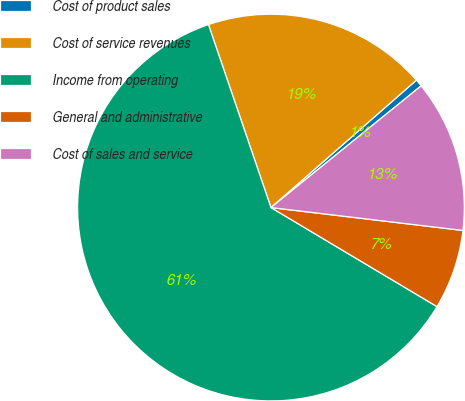<chart> <loc_0><loc_0><loc_500><loc_500><pie_chart><fcel>Cost of product sales<fcel>Cost of service revenues<fcel>Income from operating<fcel>General and administrative<fcel>Cost of sales and service<nl><fcel>0.61%<fcel>18.79%<fcel>61.2%<fcel>6.67%<fcel>12.73%<nl></chart> 